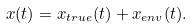Convert formula to latex. <formula><loc_0><loc_0><loc_500><loc_500>x ( t ) = x _ { t r u e } ( t ) + x _ { e n v } ( t ) .</formula> 